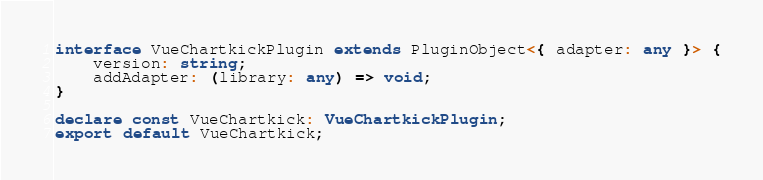<code> <loc_0><loc_0><loc_500><loc_500><_TypeScript_>interface VueChartkickPlugin extends PluginObject<{ adapter: any }> {
    version: string;
    addAdapter: (library: any) => void;
}

declare const VueChartkick: VueChartkickPlugin;
export default VueChartkick;
</code> 